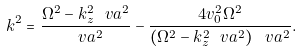<formula> <loc_0><loc_0><loc_500><loc_500>k ^ { 2 } = \frac { \Omega ^ { 2 } - k _ { z } ^ { 2 } \ v a ^ { 2 } } { \ v a ^ { 2 } } - \frac { 4 v _ { 0 } ^ { 2 } \Omega ^ { 2 } } { \left ( \Omega ^ { 2 } - k _ { z } ^ { 2 } \ v a ^ { 2 } \right ) \ v a ^ { 2 } } .</formula> 